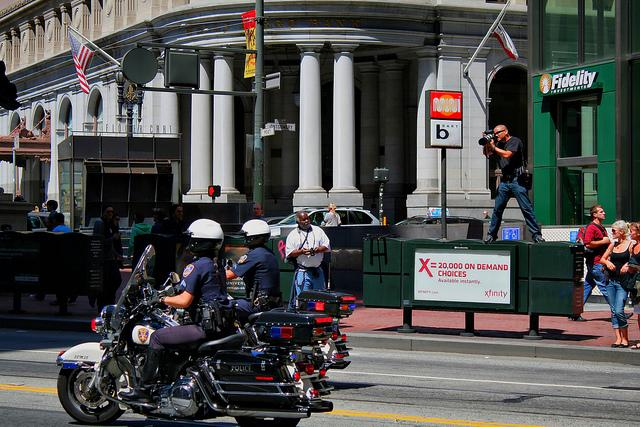What is the man standing on the green sign doing?

Choices:
A) protesting
B) exercising
C) photographing
D) dancing photographing 